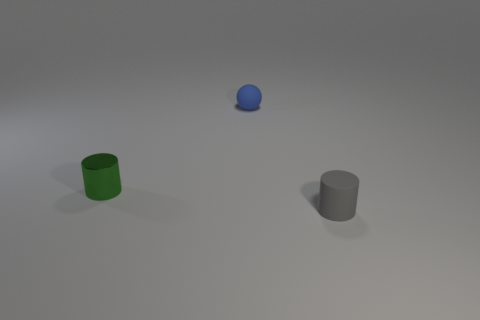There is a thing that is to the left of the object that is behind the tiny green metallic cylinder; what is it made of?
Your response must be concise. Metal. Are the ball and the cylinder that is behind the tiny gray rubber cylinder made of the same material?
Keep it short and to the point. No. How many things are either cylinders to the right of the green object or large purple rubber objects?
Your answer should be compact. 1. Are there any small balls of the same color as the rubber cylinder?
Provide a short and direct response. No. There is a small gray rubber thing; does it have the same shape as the matte thing that is behind the gray matte thing?
Your answer should be very brief. No. What number of small objects are in front of the small blue matte sphere and left of the tiny gray rubber thing?
Provide a short and direct response. 1. There is another gray object that is the same shape as the shiny thing; what is its material?
Offer a terse response. Rubber. Are any tiny red shiny spheres visible?
Offer a very short reply. No. The object that is in front of the small sphere and to the right of the tiny green cylinder is made of what material?
Ensure brevity in your answer.  Rubber. Is the number of tiny cylinders on the right side of the blue object greater than the number of tiny metal cylinders in front of the tiny gray cylinder?
Provide a short and direct response. Yes. 